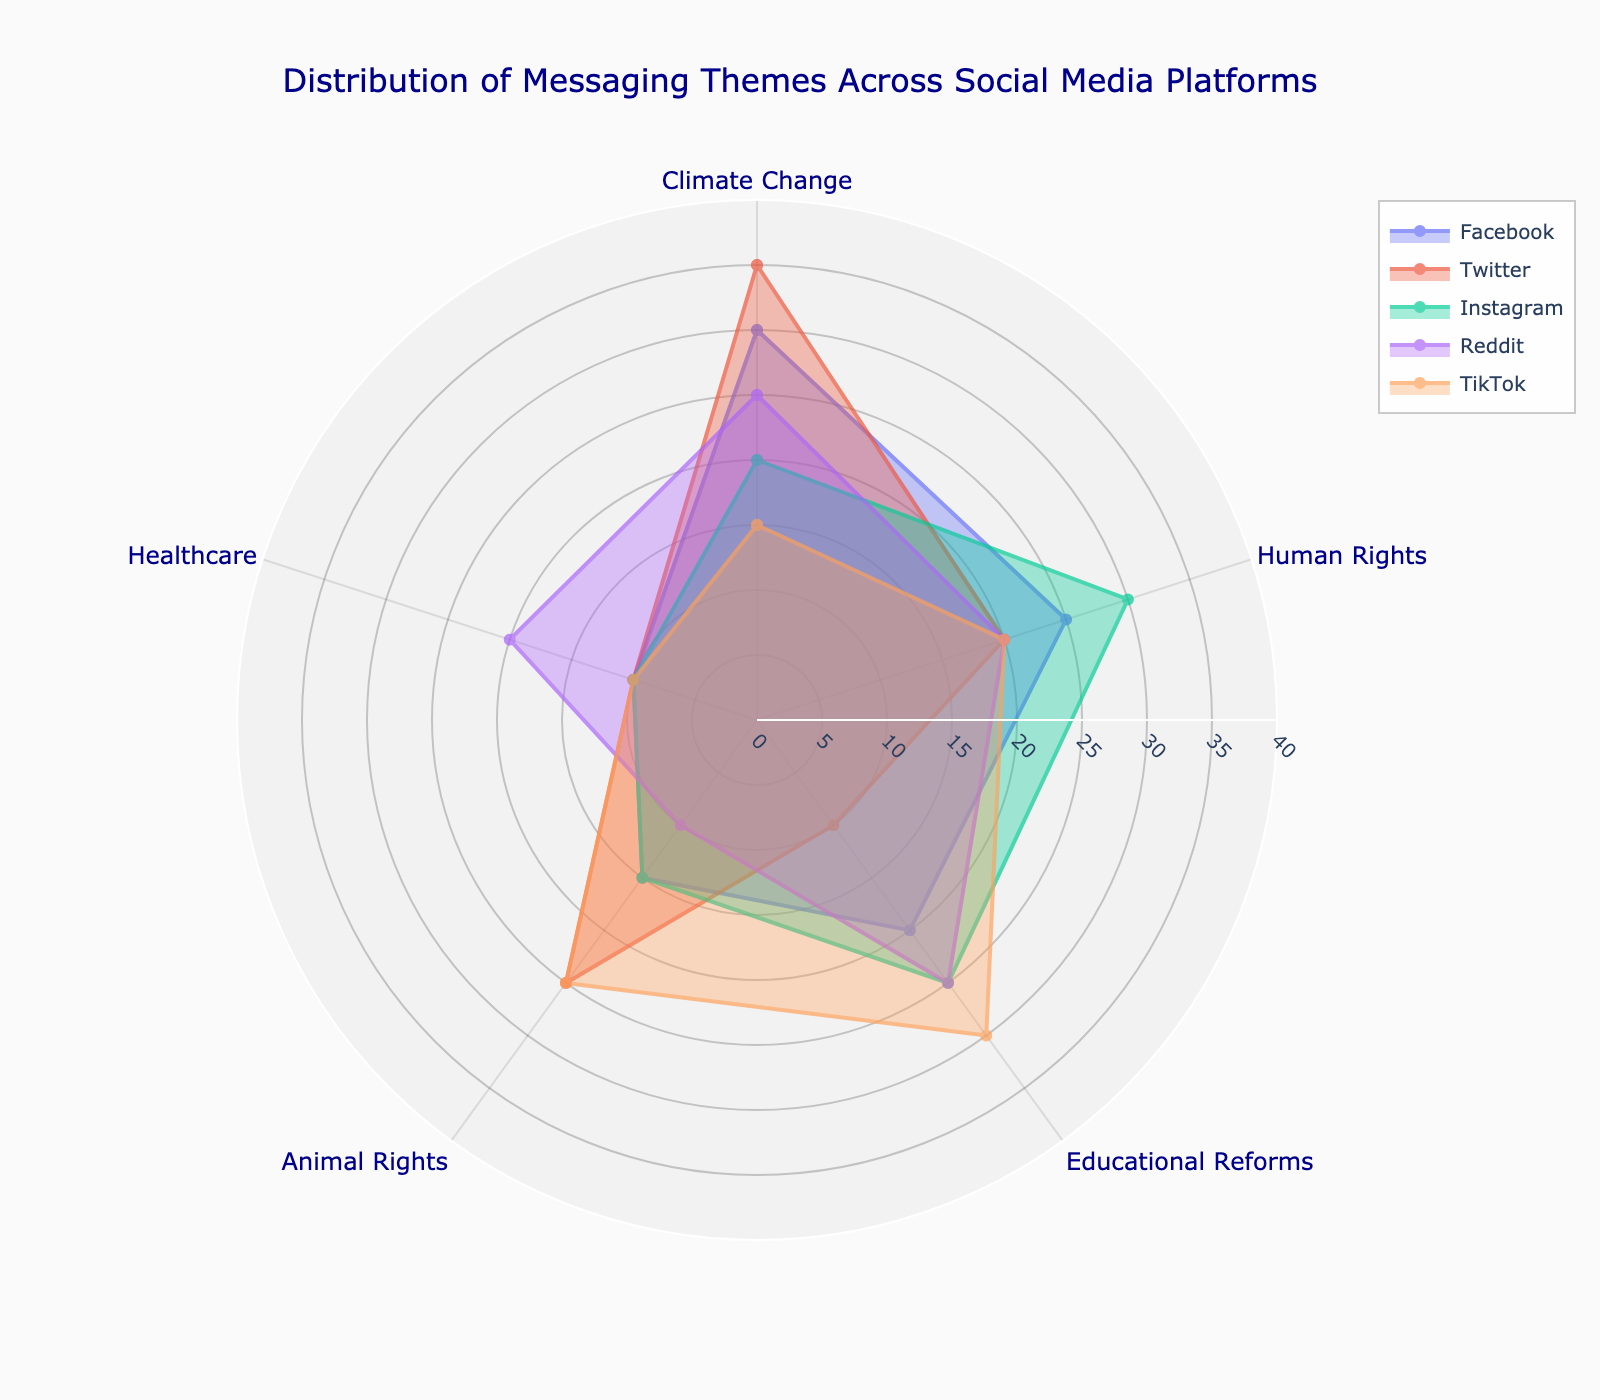What is the title of the Polar Chart? The title is typically located at the top of the chart and summarizes the content.
Answer: Distribution of Messaging Themes Across Social Media Platforms Which theme has the highest percentage on Facebook? On the polar chart, find the segment for Facebook and identify the longest radial line corresponding to the themes. The theme with the longest line has the highest percentage.
Answer: Climate Change What is the sum of percentages for Educational Reforms across all platforms? Add the values of Educational Reforms from Facebook (20%), Twitter (10%), Instagram (25%), Reddit (25%), and TikTok (30%).
Answer: 110% Which platform has the smallest percentage for Animal Rights? Locate the Animal Rights sections for each platform and note their percentages. Compare the values to find the smallest one.
Answer: Reddit On which platform is Human Rights the dominant theme? For each platform, check the percentages of each theme and identify where Human Rights has the highest percentage.
Answer: Instagram Compare the Healthcare percentage on Twitter and Instagram. Which one is higher? Look at the radial lines for Healthcare on both Twitter and Instagram and compare their lengths. The longer line indicates the higher percentage.
Answer: They are equal What is the average percentage of Climate Change theme across all platforms? Sum the percentages of Climate Change for each platform (Facebook 30%, Twitter 35%, Instagram 20%, Reddit 25%, TikTok 15%), then divide by the number of platforms (5). (30+35+20+25+15) / 5 = 25
Answer: 25% Which platform shows the least variation in theme percentages? Examine the spread of radial lines for each platform and identify which one has the most uniform lengths of lines.
Answer: TikTok 